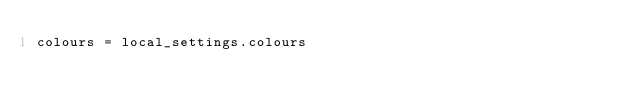Convert code to text. <code><loc_0><loc_0><loc_500><loc_500><_Python_>colours = local_settings.colours</code> 